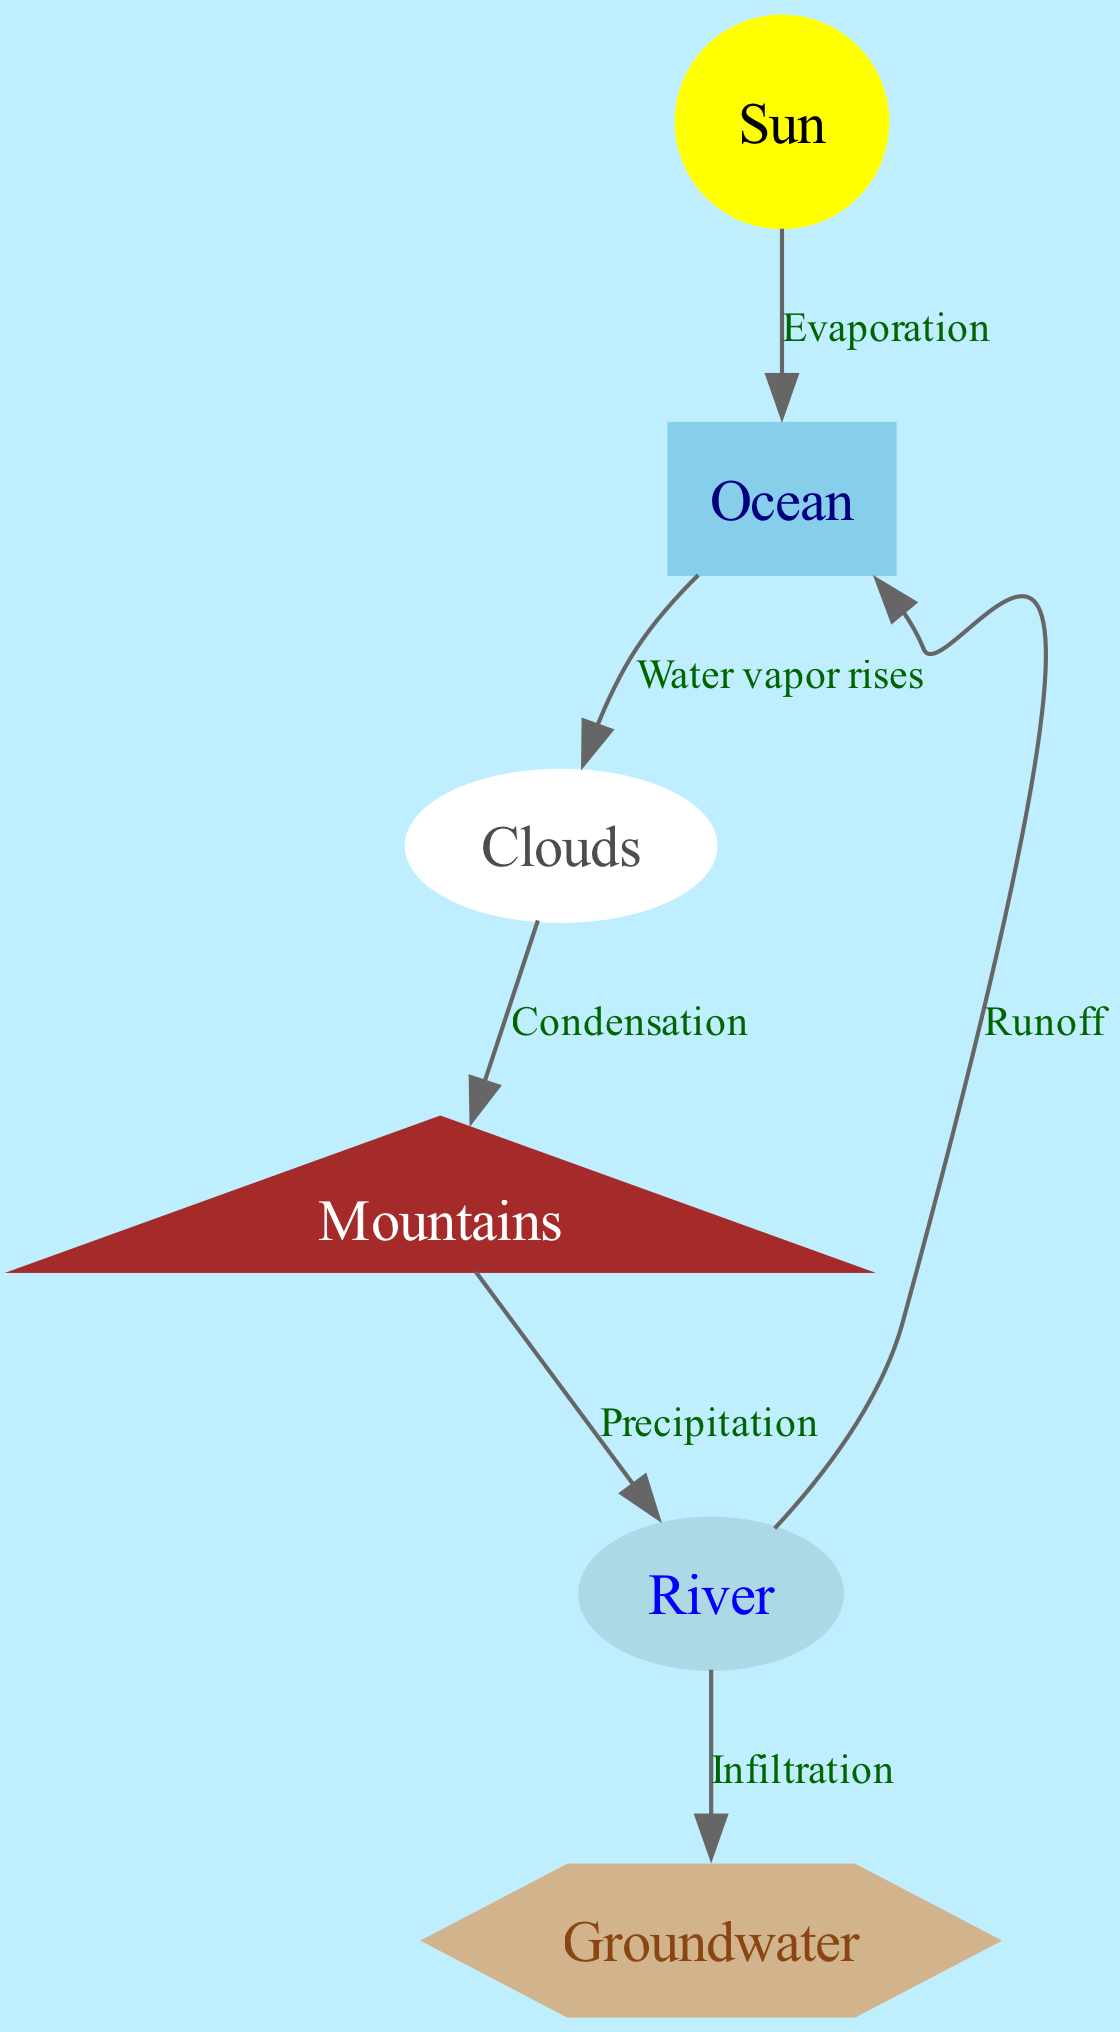What are the six nodes shown in the diagram? The diagram includes six nodes representing elements of the water cycle: Sun, Ocean, Clouds, Mountains, River, and Groundwater.
Answer: Sun, Ocean, Clouds, Mountains, River, Groundwater Which process connects the Sun and the Ocean? The edge connecting the Sun and the Ocean is labeled "Evaporation," indicating that the Sun's heat causes water to evaporate from the Ocean.
Answer: Evaporation How many total edges are displayed in the diagram? There are a total of six directed edges in the diagram representing the processes of the water cycle.
Answer: 6 What follows condensation in the water cycle according to the diagram? After condensation, the diagram shows that precipitation occurs next, indicating that water falls from clouds.
Answer: Precipitation Through which process does water return from the River to the Ocean? The edge labeled "Runoff" illustrates the process by which water returns from the River to the Ocean.
Answer: Runoff What happens to some of the water from the River, as indicated in the diagram? The diagram indicates that some water from the River goes into the Groundwater through the process labeled "Infiltration."
Answer: Infiltration Which node is the starting point of evaporation in the diagram? The Sun is the starting point of evaporation in the water cycle diagram, as it provides the heat necessary for this process.
Answer: Sun In which direction does water vapor rise from the Ocean? Water vapor rises from the Ocean to the Clouds, as indicated by the directional edge labeled "Water vapor rises."
Answer: Clouds 